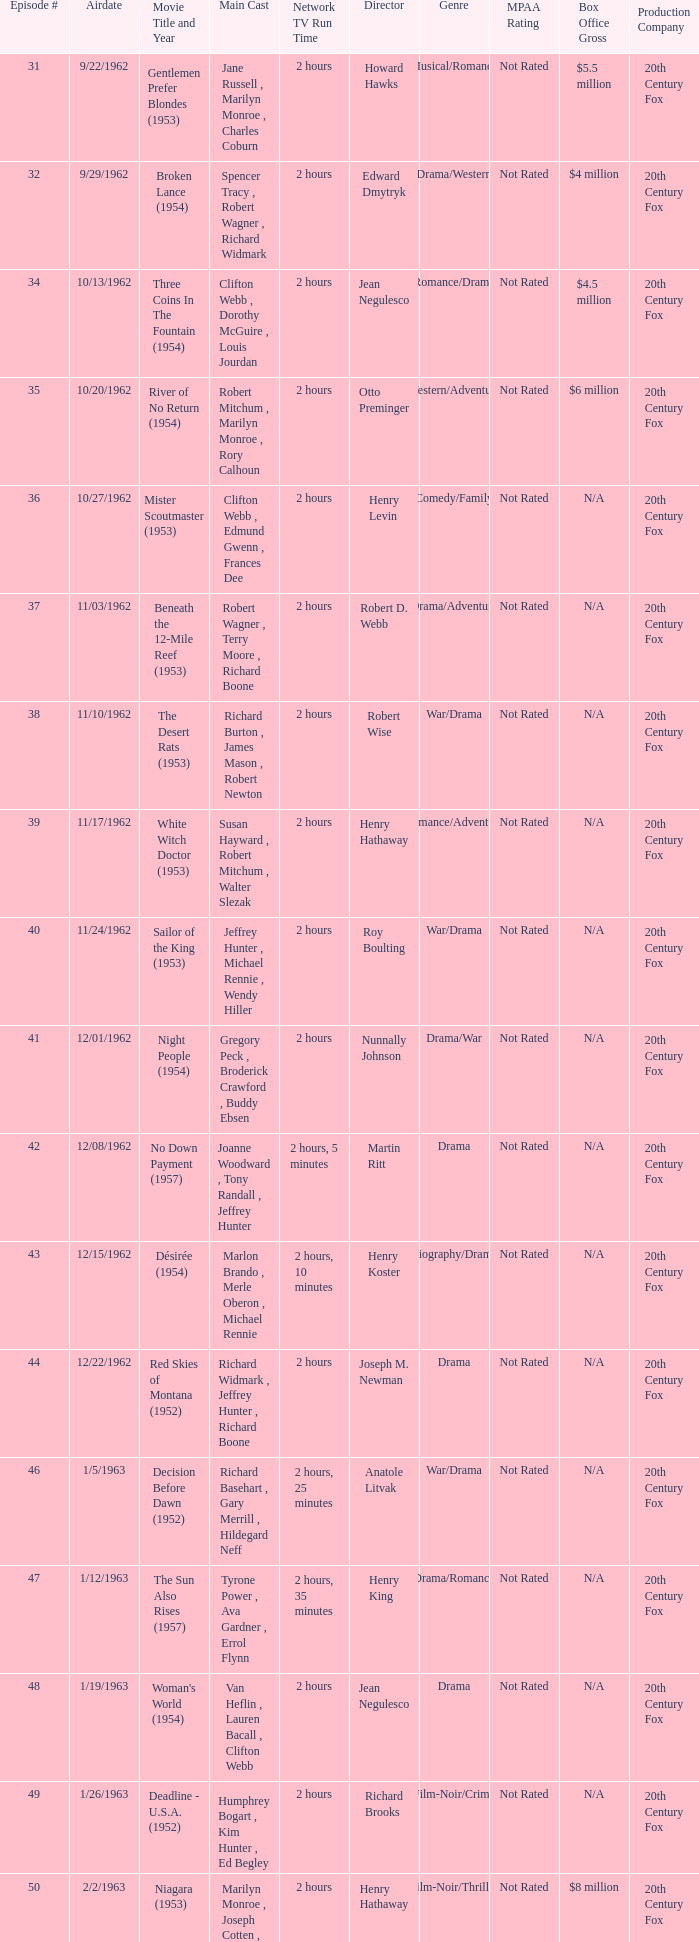What movie did dana wynter , mel ferrer , theodore bikel star in? Fraulein (1958). 